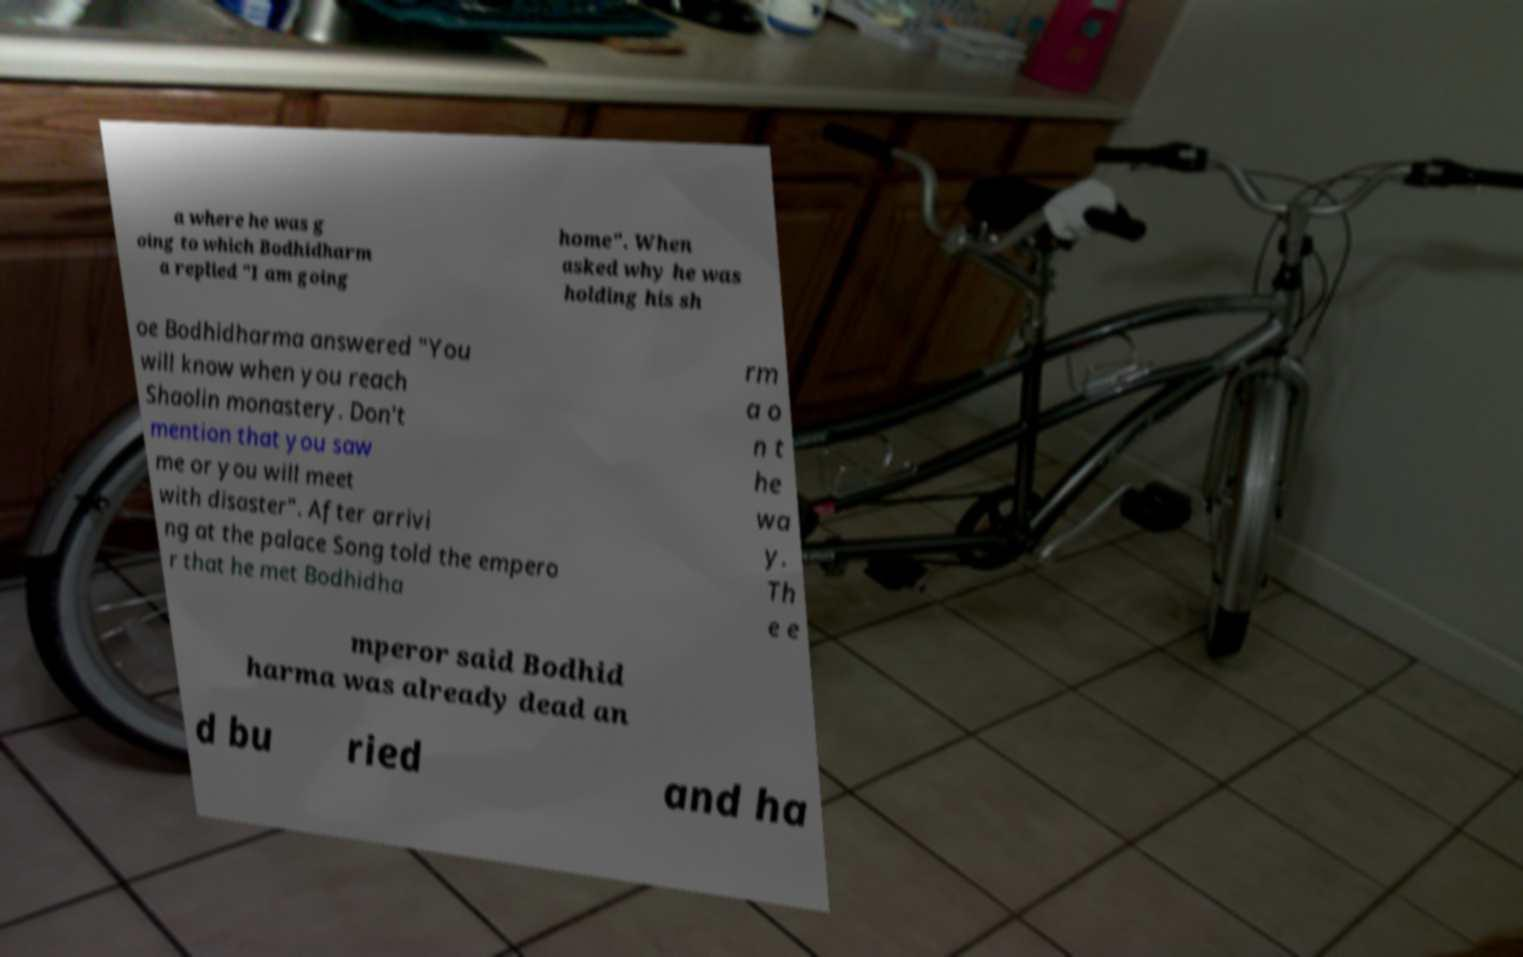Could you assist in decoding the text presented in this image and type it out clearly? a where he was g oing to which Bodhidharm a replied "I am going home". When asked why he was holding his sh oe Bodhidharma answered "You will know when you reach Shaolin monastery. Don't mention that you saw me or you will meet with disaster". After arrivi ng at the palace Song told the empero r that he met Bodhidha rm a o n t he wa y. Th e e mperor said Bodhid harma was already dead an d bu ried and ha 